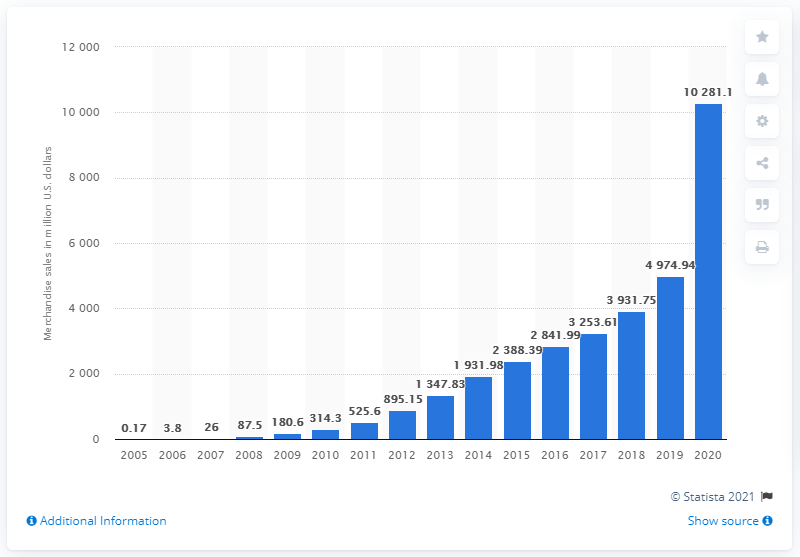What does the overall trend in the graph suggest about Etsy's growth? The trend in the graph demonstrates a consistent upward trajectory in Etsy's merchandise sales volume over the years. Starting from modest figures in the early 2000s, there has been a significant year-over-year growth, with particularly steep inclines observed in the latter part of the depicted timeline. This pattern suggests robust expansion and increasing traction for Etsy's marketplace. 